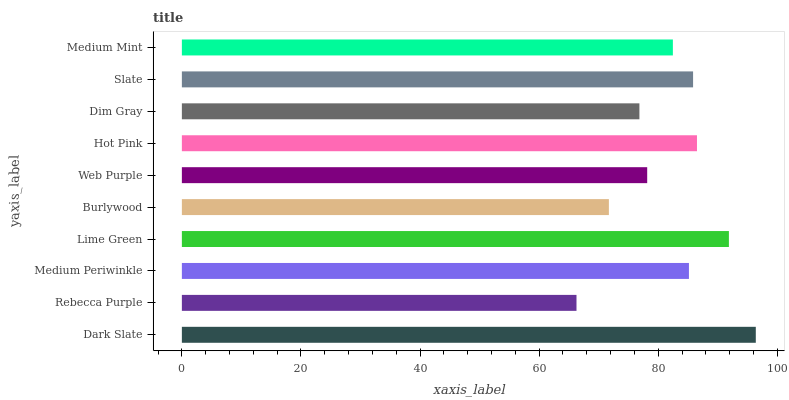Is Rebecca Purple the minimum?
Answer yes or no. Yes. Is Dark Slate the maximum?
Answer yes or no. Yes. Is Medium Periwinkle the minimum?
Answer yes or no. No. Is Medium Periwinkle the maximum?
Answer yes or no. No. Is Medium Periwinkle greater than Rebecca Purple?
Answer yes or no. Yes. Is Rebecca Purple less than Medium Periwinkle?
Answer yes or no. Yes. Is Rebecca Purple greater than Medium Periwinkle?
Answer yes or no. No. Is Medium Periwinkle less than Rebecca Purple?
Answer yes or no. No. Is Medium Periwinkle the high median?
Answer yes or no. Yes. Is Medium Mint the low median?
Answer yes or no. Yes. Is Hot Pink the high median?
Answer yes or no. No. Is Hot Pink the low median?
Answer yes or no. No. 